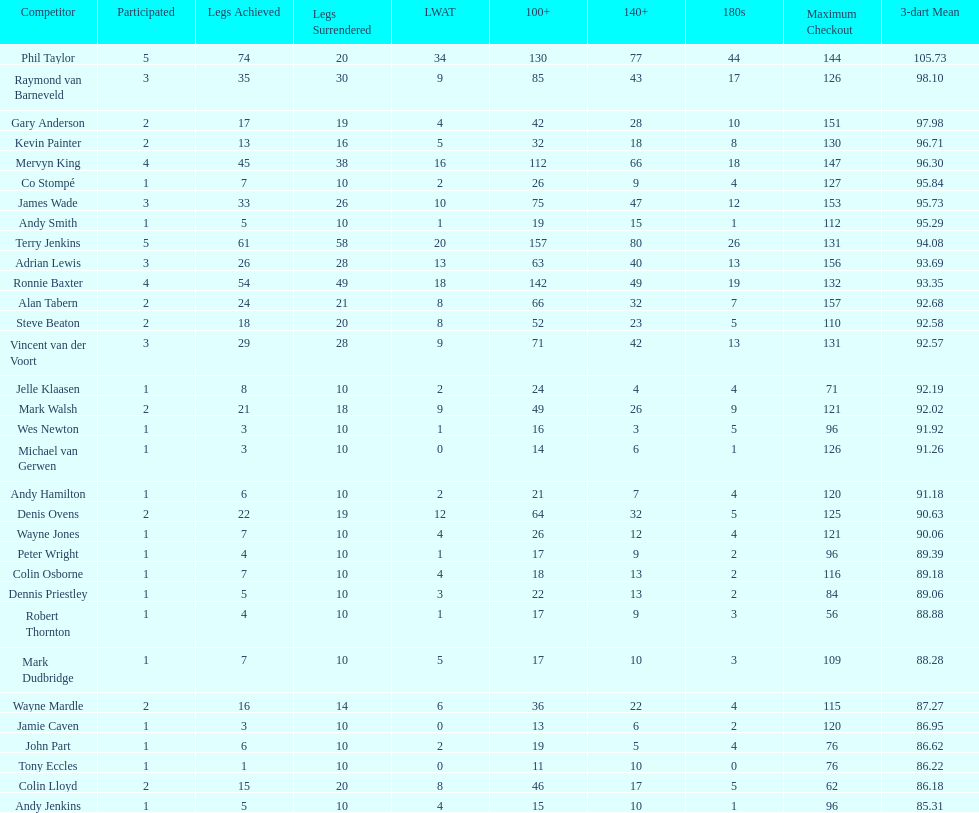Who achieved a high checkout of 116 in their career? Colin Osborne. 